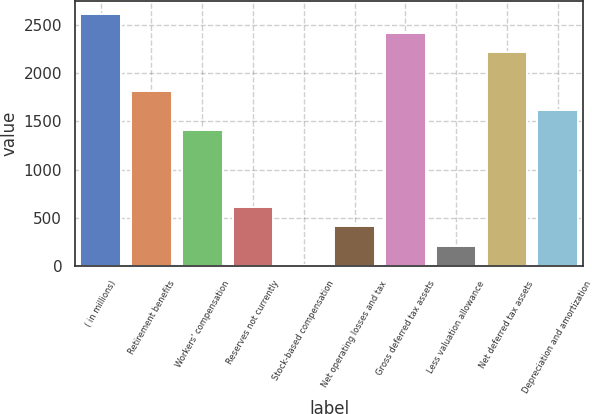<chart> <loc_0><loc_0><loc_500><loc_500><bar_chart><fcel>( in millions)<fcel>Retirement benefits<fcel>Workers' compensation<fcel>Reserves not currently<fcel>Stock-based compensation<fcel>Net operating losses and tax<fcel>Gross deferred tax assets<fcel>Less valuation allowance<fcel>Net deferred tax assets<fcel>Depreciation and amortization<nl><fcel>2618.8<fcel>1816.4<fcel>1415.2<fcel>612.8<fcel>11<fcel>412.2<fcel>2418.2<fcel>211.6<fcel>2217.6<fcel>1615.8<nl></chart> 